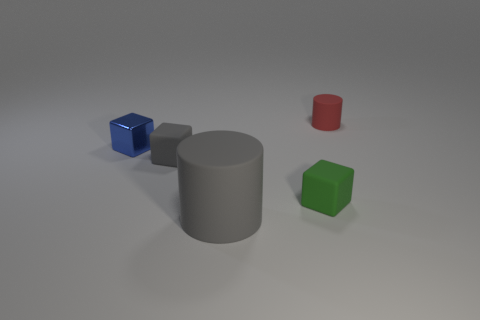There is a cylinder that is to the left of the rubber object that is behind the blue thing; what is its size?
Your response must be concise. Large. Do the cylinder to the left of the small red thing and the rubber cube right of the small gray thing have the same color?
Ensure brevity in your answer.  No. The block that is both to the left of the tiny green rubber cube and on the right side of the blue cube is what color?
Ensure brevity in your answer.  Gray. How many other things are the same shape as the tiny gray matte object?
Provide a succinct answer. 2. What color is the metal thing that is the same size as the gray block?
Make the answer very short. Blue. What color is the cylinder that is in front of the metal thing?
Your answer should be very brief. Gray. There is a rubber cylinder in front of the small green matte thing; are there any large rubber cylinders that are left of it?
Your answer should be compact. No. There is a shiny object; does it have the same shape as the tiny thing behind the small shiny cube?
Your answer should be very brief. No. There is a block that is behind the green matte cube and in front of the blue block; how big is it?
Your answer should be compact. Small. Is there a tiny green sphere made of the same material as the tiny red thing?
Your answer should be very brief. No. 